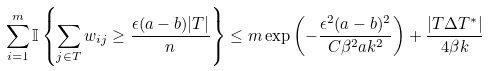<formula> <loc_0><loc_0><loc_500><loc_500>\sum _ { i = 1 } ^ { m } \mathbb { I } \left \{ \sum _ { j \in T } w _ { i j } \geq \frac { \epsilon ( a - b ) | T | } { n } \right \} \leq m \exp \left ( - \frac { \epsilon ^ { 2 } ( a - b ) ^ { 2 } } { C \beta ^ { 2 } a k ^ { 2 } } \right ) + \frac { | T \Delta T ^ { * } | } { 4 \beta k }</formula> 